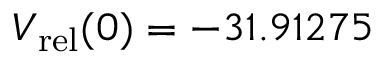Convert formula to latex. <formula><loc_0><loc_0><loc_500><loc_500>V _ { r e l } ( 0 ) = - 3 1 . 9 1 2 7 5</formula> 